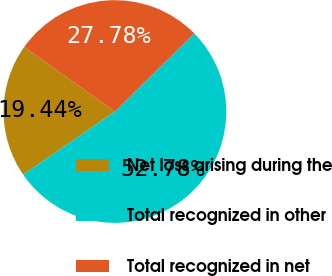<chart> <loc_0><loc_0><loc_500><loc_500><pie_chart><fcel>Net loss arising during the<fcel>Total recognized in other<fcel>Total recognized in net<nl><fcel>19.44%<fcel>52.78%<fcel>27.78%<nl></chart> 